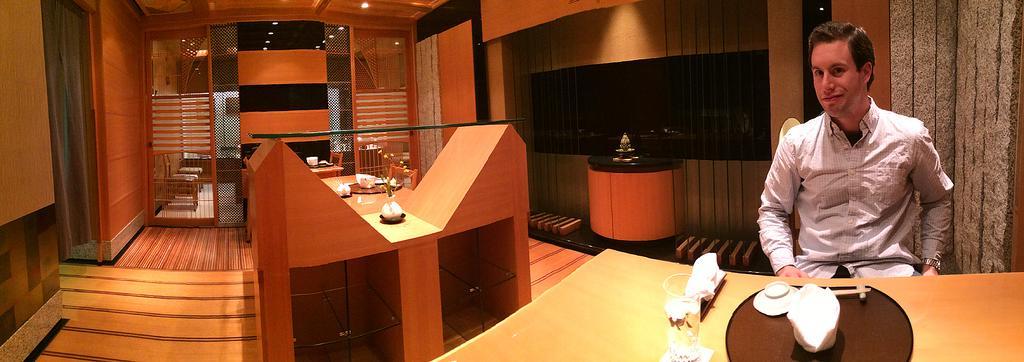How would you summarize this image in a sentence or two? This person sitting and smiling. We can see tables,chairs,furniture,on the table there are glass,cups,tissues,plates. On the top we can see lights and on the top we can see wall. This is floor. 